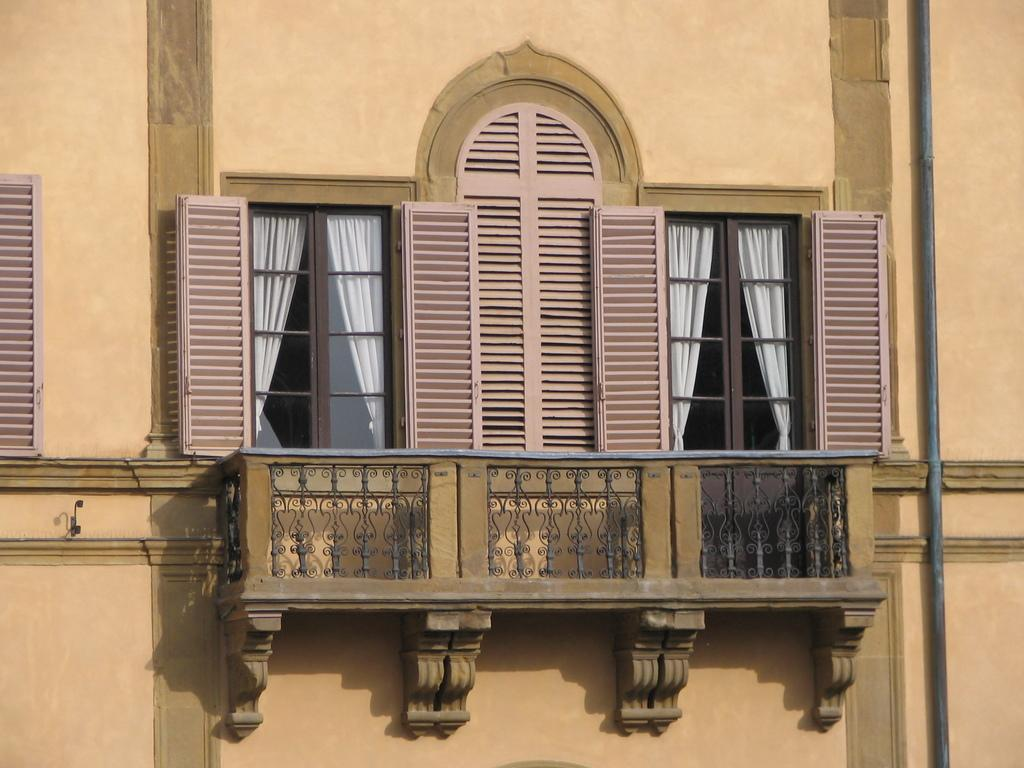What type of structure can be seen in the image? There is railing in the image, which suggests a balcony or staircase. What can be seen through the windows in the image? There are windows in the image, and they have curtains. What is located on the right side of the image? There is a pipeline on the right side of the image. How many sisters are visible in the image? There are no sisters present in the image. What type of bait is used to catch fish in the image? There is no fishing or bait present in the image. 